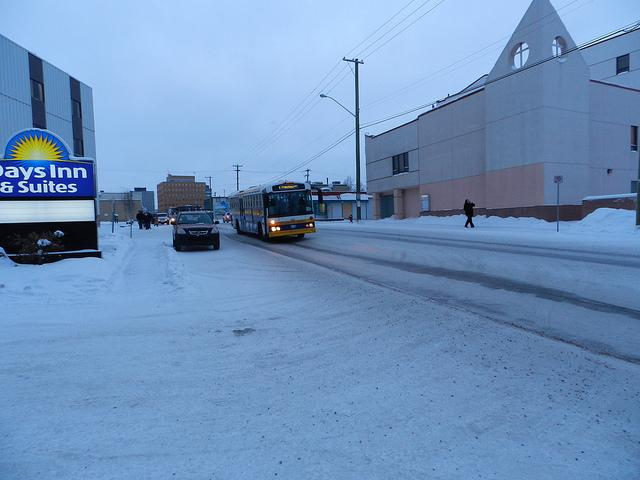What kind of building is the one with the sign on the left? hotel 